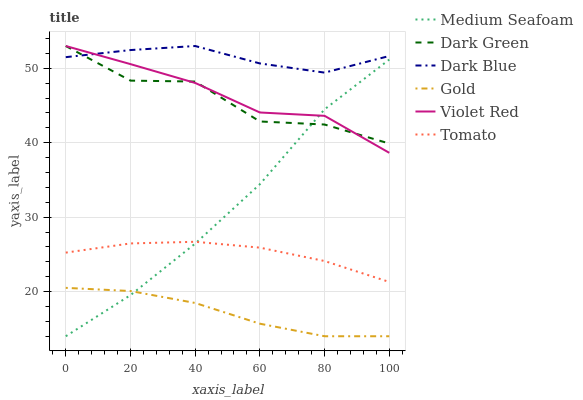Does Gold have the minimum area under the curve?
Answer yes or no. Yes. Does Dark Blue have the maximum area under the curve?
Answer yes or no. Yes. Does Violet Red have the minimum area under the curve?
Answer yes or no. No. Does Violet Red have the maximum area under the curve?
Answer yes or no. No. Is Tomato the smoothest?
Answer yes or no. Yes. Is Dark Green the roughest?
Answer yes or no. Yes. Is Violet Red the smoothest?
Answer yes or no. No. Is Violet Red the roughest?
Answer yes or no. No. Does Gold have the lowest value?
Answer yes or no. Yes. Does Violet Red have the lowest value?
Answer yes or no. No. Does Dark Green have the highest value?
Answer yes or no. Yes. Does Gold have the highest value?
Answer yes or no. No. Is Tomato less than Violet Red?
Answer yes or no. Yes. Is Dark Green greater than Tomato?
Answer yes or no. Yes. Does Dark Green intersect Medium Seafoam?
Answer yes or no. Yes. Is Dark Green less than Medium Seafoam?
Answer yes or no. No. Is Dark Green greater than Medium Seafoam?
Answer yes or no. No. Does Tomato intersect Violet Red?
Answer yes or no. No. 